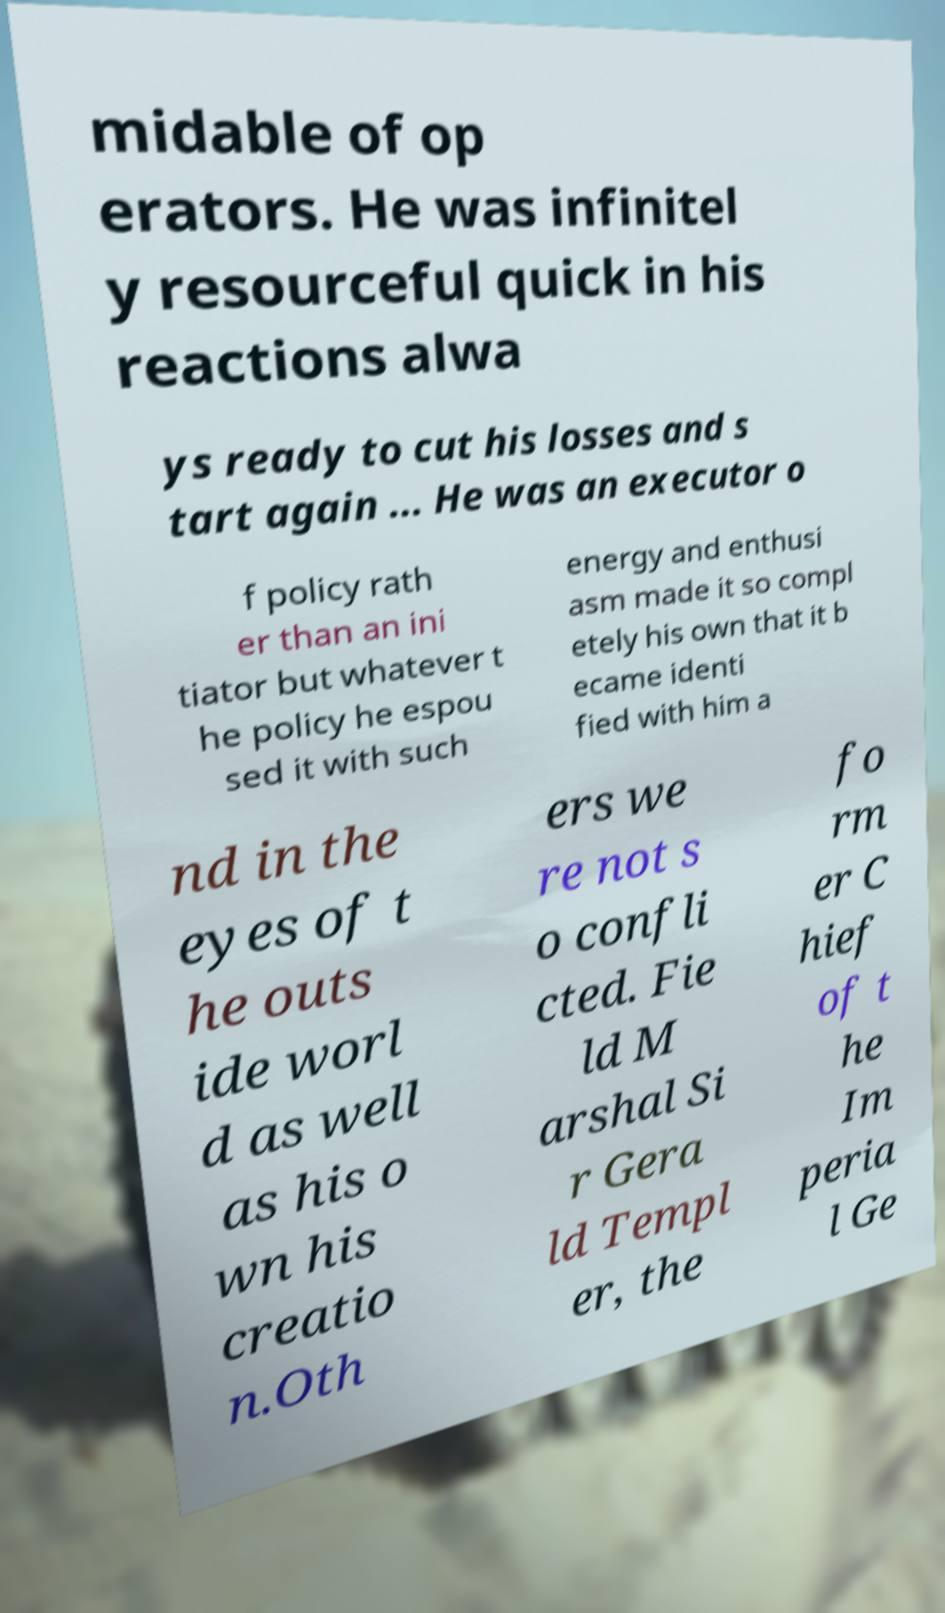I need the written content from this picture converted into text. Can you do that? midable of op erators. He was infinitel y resourceful quick in his reactions alwa ys ready to cut his losses and s tart again ... He was an executor o f policy rath er than an ini tiator but whatever t he policy he espou sed it with such energy and enthusi asm made it so compl etely his own that it b ecame identi fied with him a nd in the eyes of t he outs ide worl d as well as his o wn his creatio n.Oth ers we re not s o confli cted. Fie ld M arshal Si r Gera ld Templ er, the fo rm er C hief of t he Im peria l Ge 